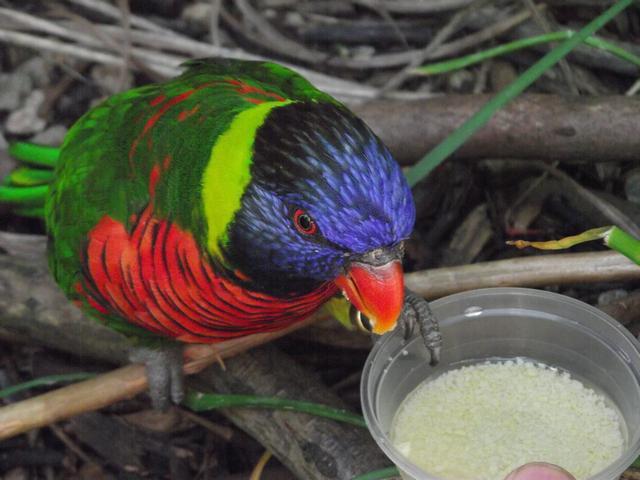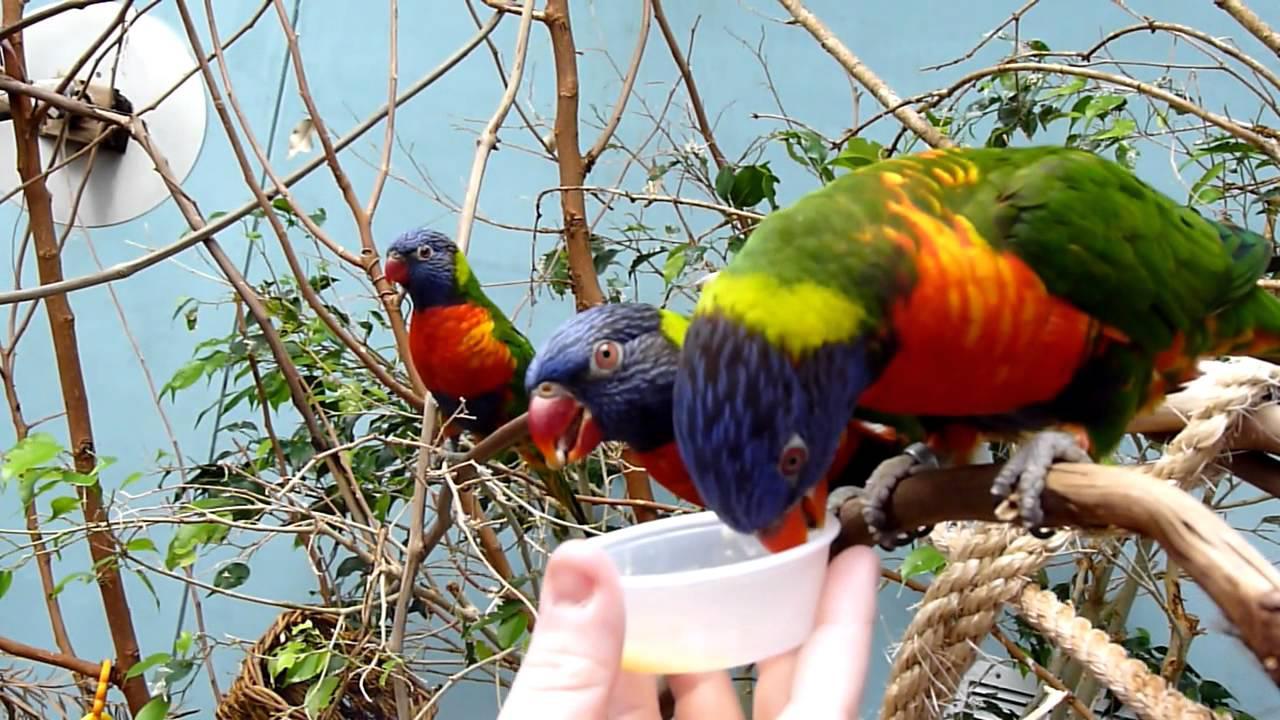The first image is the image on the left, the second image is the image on the right. Considering the images on both sides, is "There are at least two colorful parrots in the right image." valid? Answer yes or no. Yes. The first image is the image on the left, the second image is the image on the right. Examine the images to the left and right. Is the description "Each image contains a single bird, and at least one bird is pictured near a flower with tendril-like petals." accurate? Answer yes or no. No. 